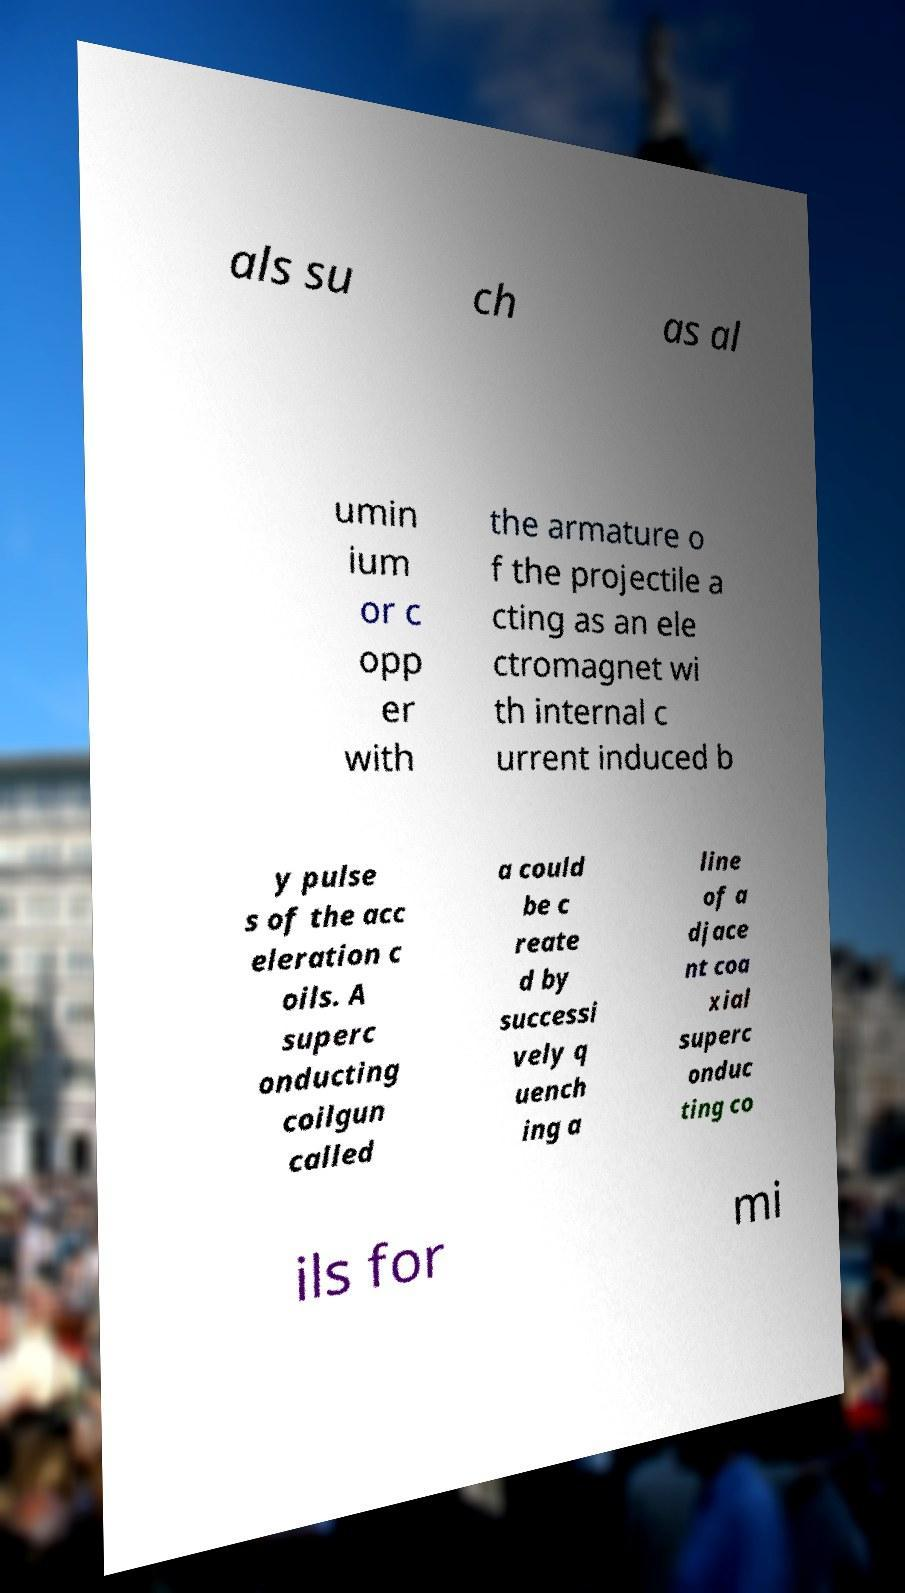There's text embedded in this image that I need extracted. Can you transcribe it verbatim? als su ch as al umin ium or c opp er with the armature o f the projectile a cting as an ele ctromagnet wi th internal c urrent induced b y pulse s of the acc eleration c oils. A superc onducting coilgun called a could be c reate d by successi vely q uench ing a line of a djace nt coa xial superc onduc ting co ils for mi 